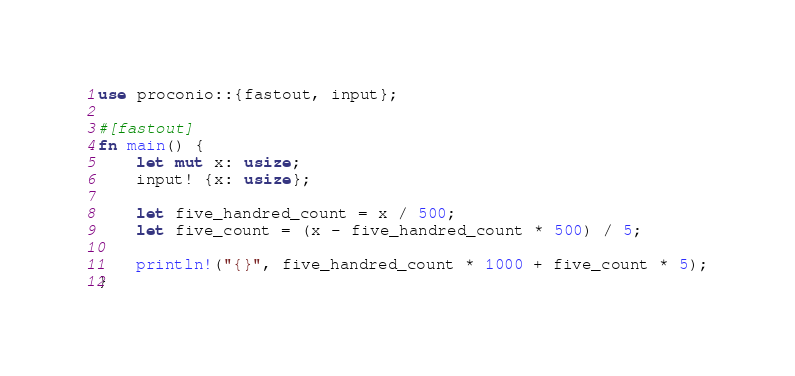<code> <loc_0><loc_0><loc_500><loc_500><_Rust_>use proconio::{fastout, input};

#[fastout]
fn main() {
    let mut x: usize;
    input! {x: usize};

    let five_handred_count = x / 500;
    let five_count = (x - five_handred_count * 500) / 5;

    println!("{}", five_handred_count * 1000 + five_count * 5);
}
</code> 